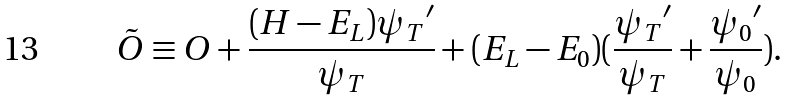<formula> <loc_0><loc_0><loc_500><loc_500>\tilde { O } \equiv O + \frac { ( H - { E _ { L } } ) { \psi _ { T } } ^ { \prime } } { \psi _ { T } } + ( { E _ { L } } - { E _ { 0 } } ) ( \frac { { \psi _ { T } } ^ { \prime } } { \psi _ { T } } + \frac { { \psi _ { 0 } } ^ { \prime } } { \psi _ { 0 } } ) .</formula> 